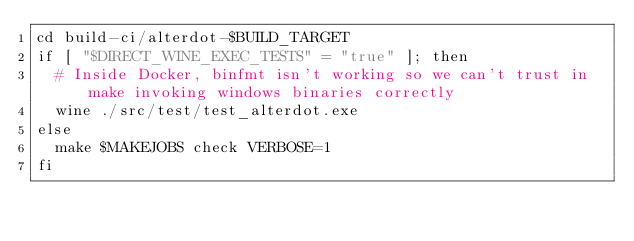Convert code to text. <code><loc_0><loc_0><loc_500><loc_500><_Bash_>cd build-ci/alterdot-$BUILD_TARGET
if [ "$DIRECT_WINE_EXEC_TESTS" = "true" ]; then
  # Inside Docker, binfmt isn't working so we can't trust in make invoking windows binaries correctly
  wine ./src/test/test_alterdot.exe
else
  make $MAKEJOBS check VERBOSE=1
fi
</code> 